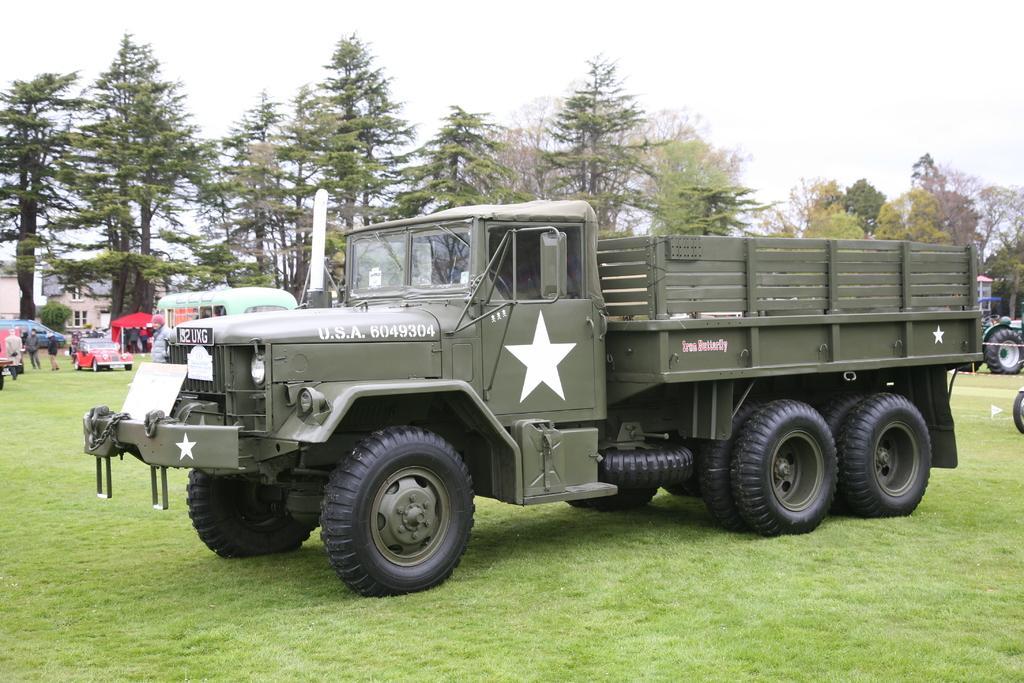Please provide a concise description of this image. In this image we can see a truck on the grassy land. Background of the image car, tempo, people and trees are present. At the top of the image sky is there. 